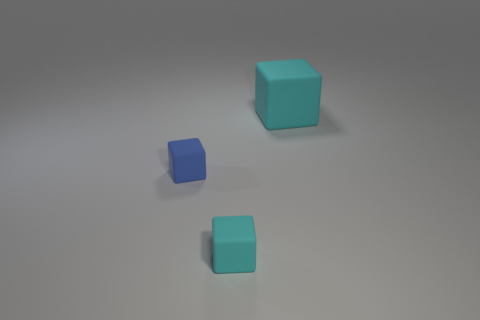Are there more tiny blue rubber blocks than cyan rubber objects?
Keep it short and to the point. No. There is a matte thing behind the object that is on the left side of the tiny cyan thing that is right of the small blue cube; what color is it?
Make the answer very short. Cyan. Do the small block that is in front of the tiny blue matte thing and the cube behind the small blue matte cube have the same color?
Offer a terse response. Yes. There is a cyan rubber cube that is behind the tiny blue rubber thing; what number of small cyan matte cubes are left of it?
Offer a terse response. 1. Are there any cyan rubber things?
Offer a very short reply. Yes. How many other things are there of the same color as the big rubber object?
Make the answer very short. 1. Is the number of small blue rubber blocks less than the number of tiny yellow matte cylinders?
Your response must be concise. No. The cyan thing in front of the thing behind the blue object is what shape?
Your answer should be very brief. Cube. There is a large object; are there any tiny cyan things right of it?
Offer a terse response. No. What color is the thing that is the same size as the blue rubber cube?
Offer a very short reply. Cyan. 